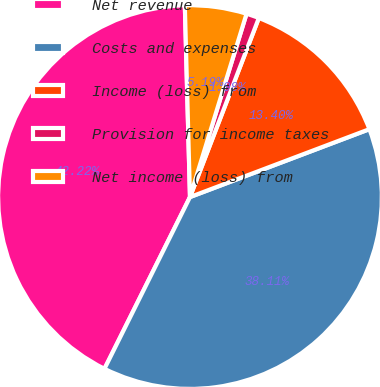Convert chart. <chart><loc_0><loc_0><loc_500><loc_500><pie_chart><fcel>Net revenue<fcel>Costs and expenses<fcel>Income (loss) from<fcel>Provision for income taxes<fcel>Net income (loss) from<nl><fcel>42.22%<fcel>38.11%<fcel>13.4%<fcel>1.08%<fcel>5.19%<nl></chart> 